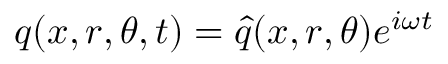Convert formula to latex. <formula><loc_0><loc_0><loc_500><loc_500>q ( x , r , \theta , t ) = \hat { q } ( x , r , \theta ) e ^ { i \omega t }</formula> 